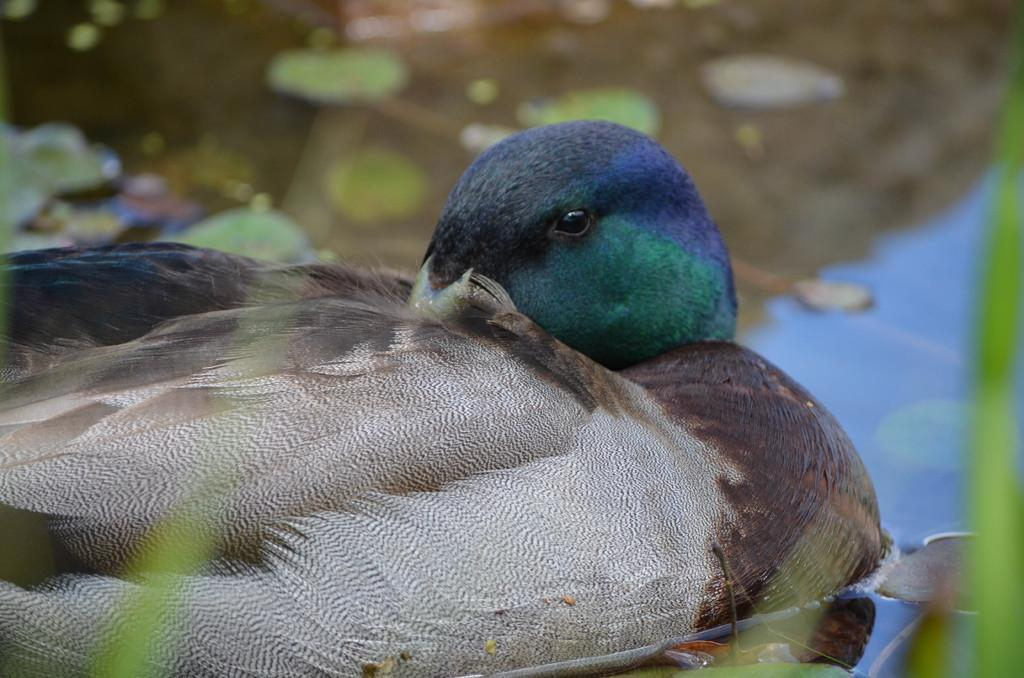What type of animal is in the image? There is a bird in the image. Can you identify the specific species of the bird? The bird is a "Mallard." What is visible behind the bird in the image? There is water visible behind the bird. How would you describe the background of the image? The background of the image is blurred. What type of frame is around the bird in the image? There is no frame around the bird in the image; it is not a photograph or artwork. What current is flowing through the water behind the bird? There is no mention of a current in the image, and the water is not described as moving. 